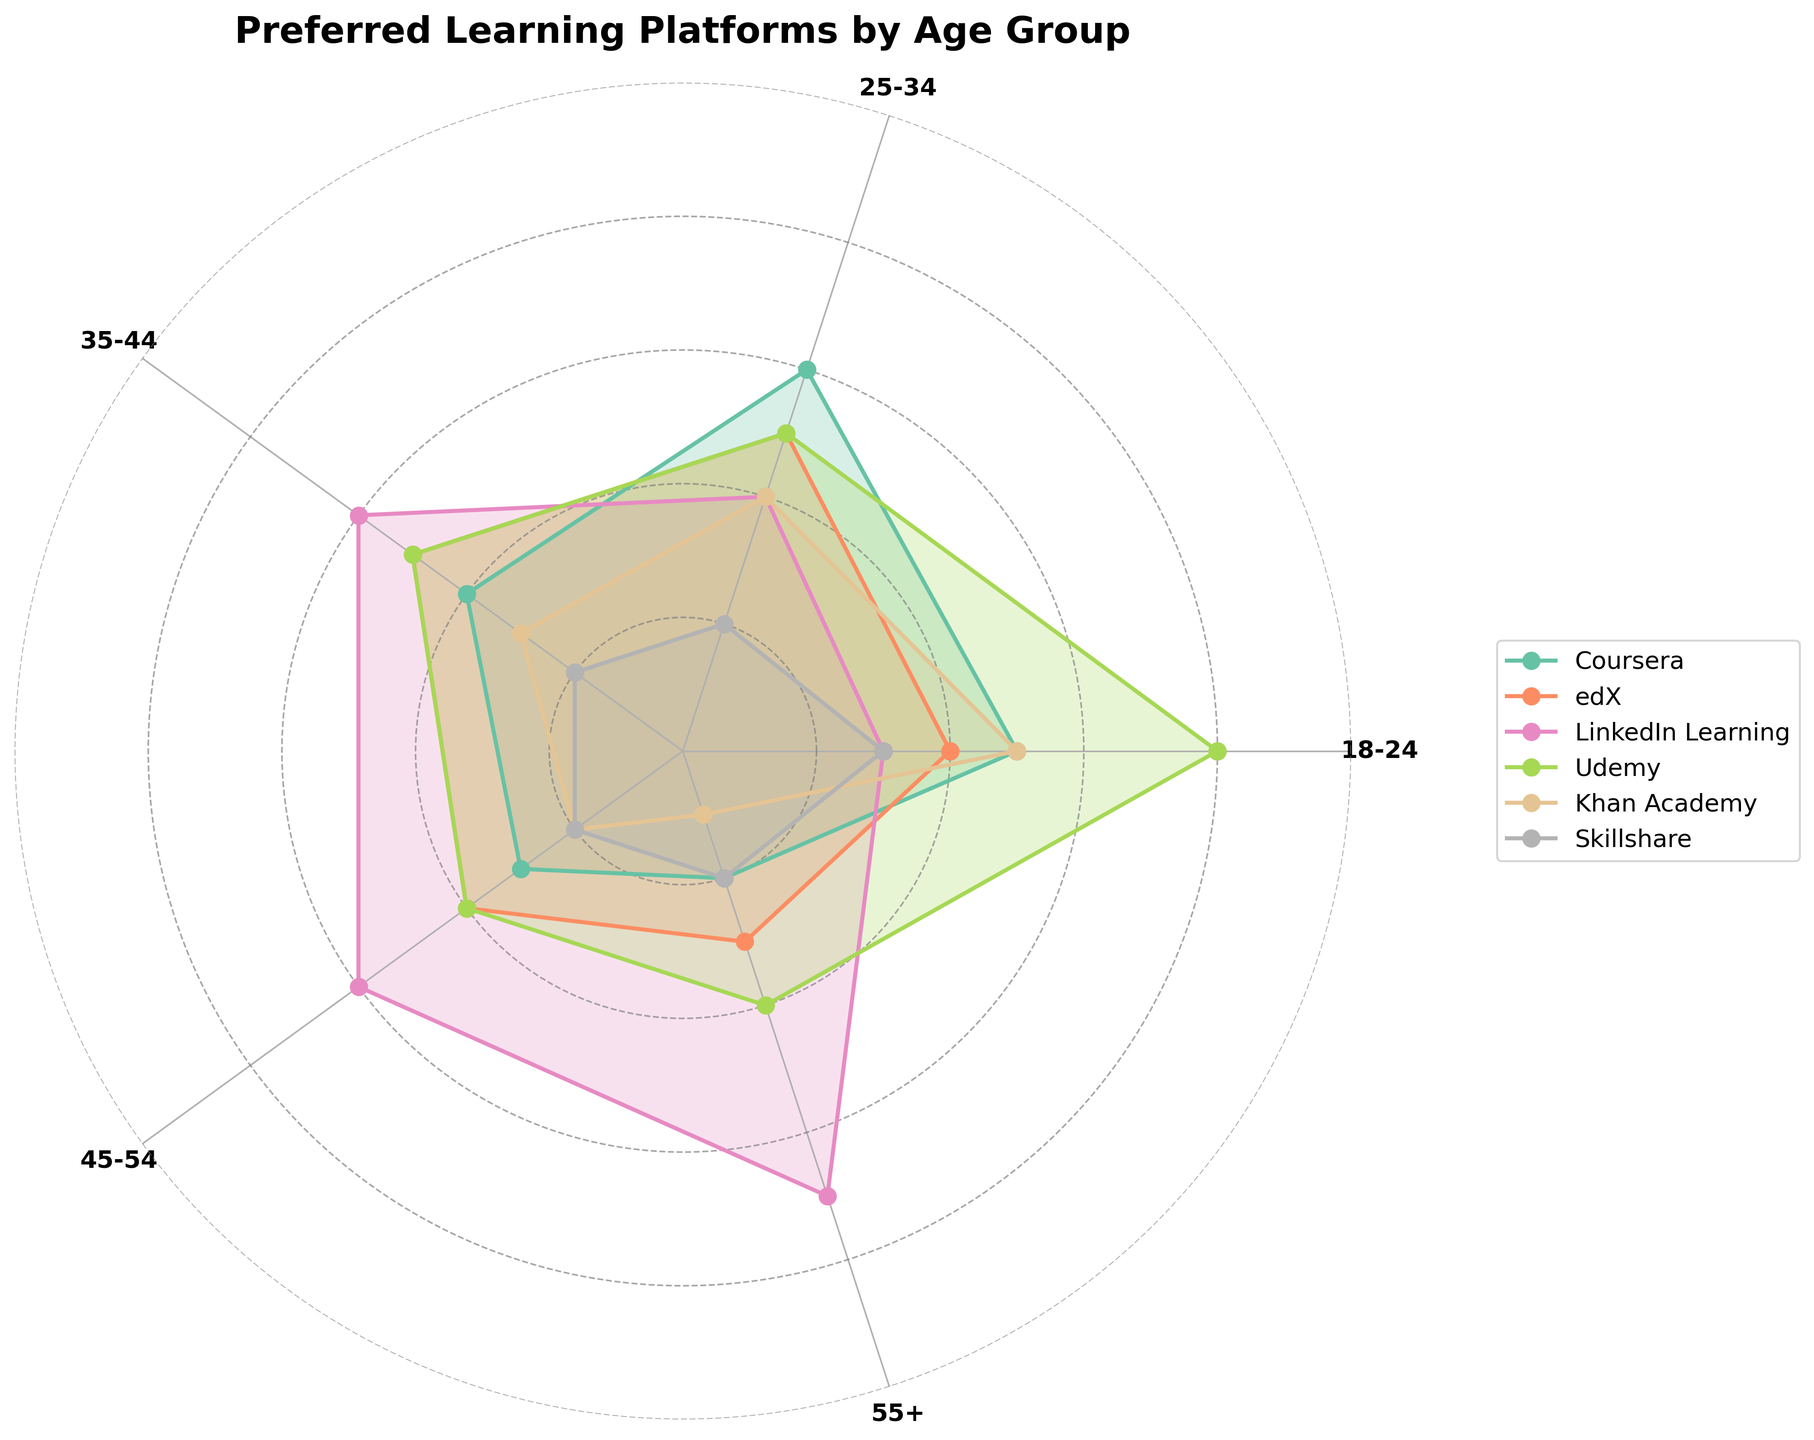What's the most preferred learning platform among the 18-24 age group? Look at the area corresponding to the 18-24 age group for each learning platform and identify which platform has the highest percentage. The biggest area for this age group is "Udemy" with a percentage of 40%.
Answer: Udemy What's the least popular learning platform among the 55+ age group? Compare the areas for the 55+ age group for each learning platform. The smallest area in this age group is "Khan Academy" with a percentage of 5%.
Answer: Khan Academy Which age group prefers LinkedIn Learning the most? Find the largest area for LinkedIn Learning among the different age groups. The age group with the largest area for LinkedIn Learning is 55+ at 35%.
Answer: 55+ Which platform has a stable preference across all age groups? Identify the platform with the most consistent percentage across age groups. "Skillshare" has percentages 15, 10, 10, 10, 10 which shows minimal variation across age groups.
Answer: Skillshare What percentage of the 25-34 age group prefers Coursera? Look at the area for Coursera within the 25-34 age group and identify the percentage value. The value is 30%.
Answer: 30% Which platform sees a decrease in preference from the 18-24 age group to the 55+ age group? Examine the areas for each platform from the 18-24 age group to the 55+ age group and identify those that show a decreasing trend. Both Coursera and Khan Academy show a decrease.
Answer: Coursera, Khan Academy What is the combined percentage preference for edX and Udemy for the 35-44 age group? Identify the percentage of preference for edX and Udemy within the 35-44 age group and sum them up. edX is 25% and Udemy is 25%, so their combined preference is 50%.
Answer: 50% Which age group is most varied in their platform preferences? Determine which age group has the widest range of percentages across the platforms. The 18-24 age group ranges from 15-40%, indicating the most variance.
Answer: 18-24 Which platform is preferred by exactly 30% of the 45-54 age group? Look at the 45-54 age group and find the platform which has exactly 30%. "LinkedIn Learning" is the platform preferred by 30%.
Answer: LinkedIn Learning How does the preference for Coursera change from the 25-34 age group to the 35-44 age group? Find the percentage of preference for Coursera in the 25-34 and 35-44 age groups and compare them. The preference goes from 30% in the 25-34 age group to 20% in the 35-44 age group, showing a decrease of 10%.
Answer: 10% decrease 